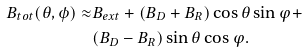Convert formula to latex. <formula><loc_0><loc_0><loc_500><loc_500>B _ { t o t } ( \theta , \phi ) \approx & B _ { e x t } + ( B _ { D } + B _ { R } ) \cos { \theta } \sin { \varphi } + \\ & ( B _ { D } - B _ { R } ) \sin { \theta } \cos { \varphi } . \\</formula> 